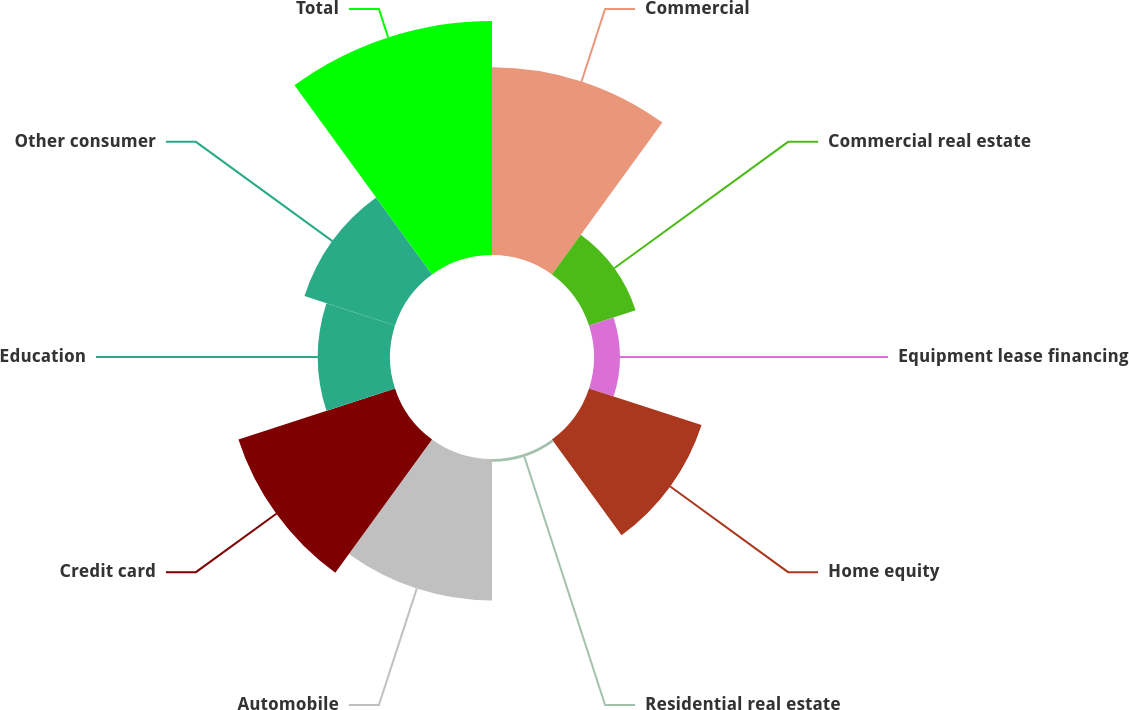<chart> <loc_0><loc_0><loc_500><loc_500><pie_chart><fcel>Commercial<fcel>Commercial real estate<fcel>Equipment lease financing<fcel>Home equity<fcel>Residential real estate<fcel>Automobile<fcel>Credit card<fcel>Education<fcel>Other consumer<fcel>Total<nl><fcel>17.21%<fcel>4.49%<fcel>2.37%<fcel>10.85%<fcel>0.25%<fcel>12.97%<fcel>15.09%<fcel>6.61%<fcel>8.73%<fcel>21.45%<nl></chart> 